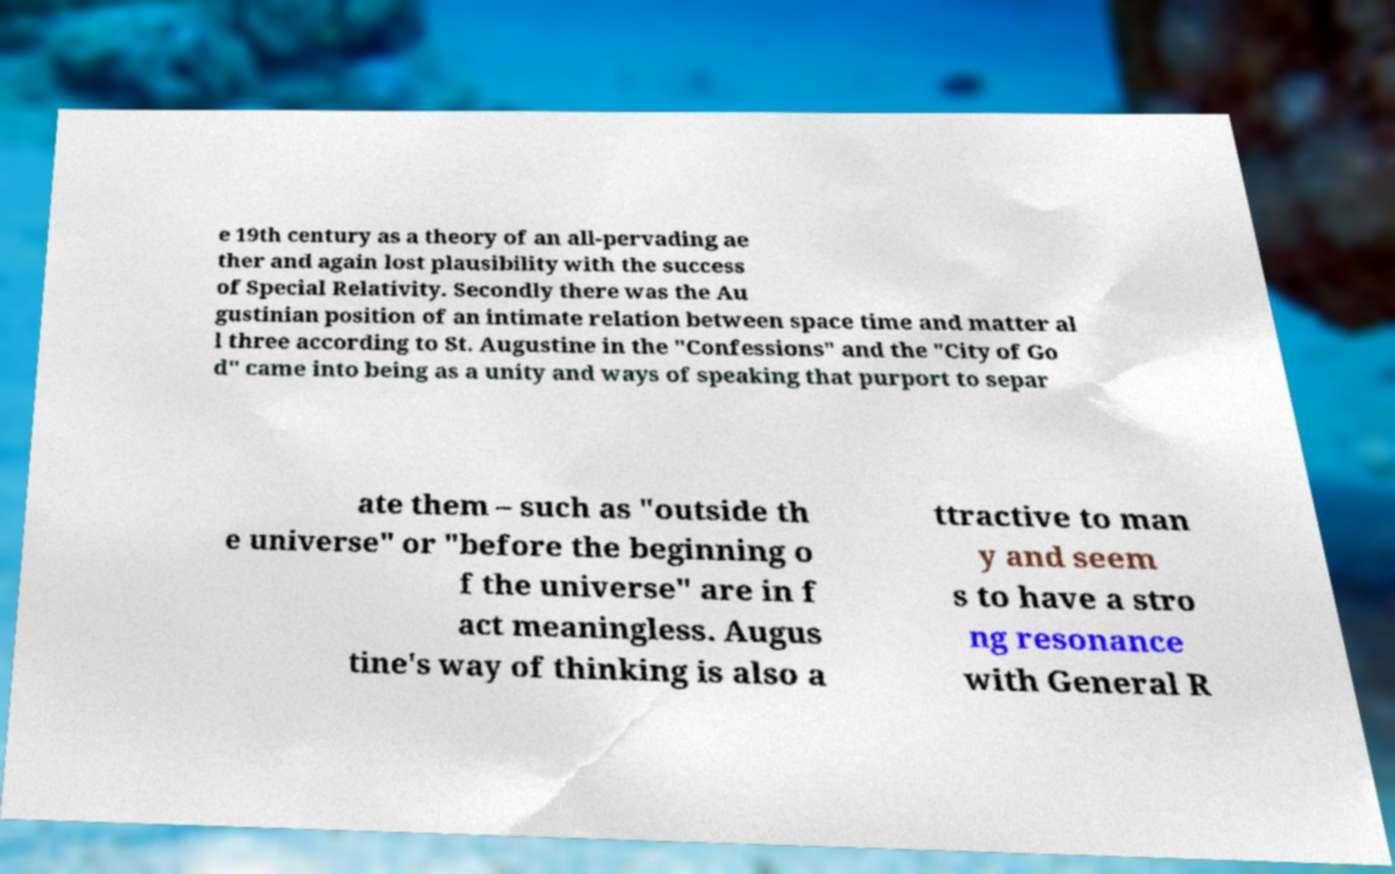What messages or text are displayed in this image? I need them in a readable, typed format. e 19th century as a theory of an all-pervading ae ther and again lost plausibility with the success of Special Relativity. Secondly there was the Au gustinian position of an intimate relation between space time and matter al l three according to St. Augustine in the "Confessions" and the "City of Go d" came into being as a unity and ways of speaking that purport to separ ate them – such as "outside th e universe" or "before the beginning o f the universe" are in f act meaningless. Augus tine's way of thinking is also a ttractive to man y and seem s to have a stro ng resonance with General R 